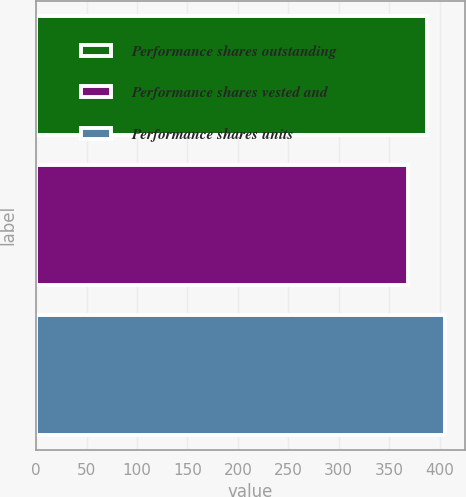Convert chart. <chart><loc_0><loc_0><loc_500><loc_500><bar_chart><fcel>Performance shares outstanding<fcel>Performance shares vested and<fcel>Performance shares units<nl><fcel>388<fcel>369<fcel>405<nl></chart> 